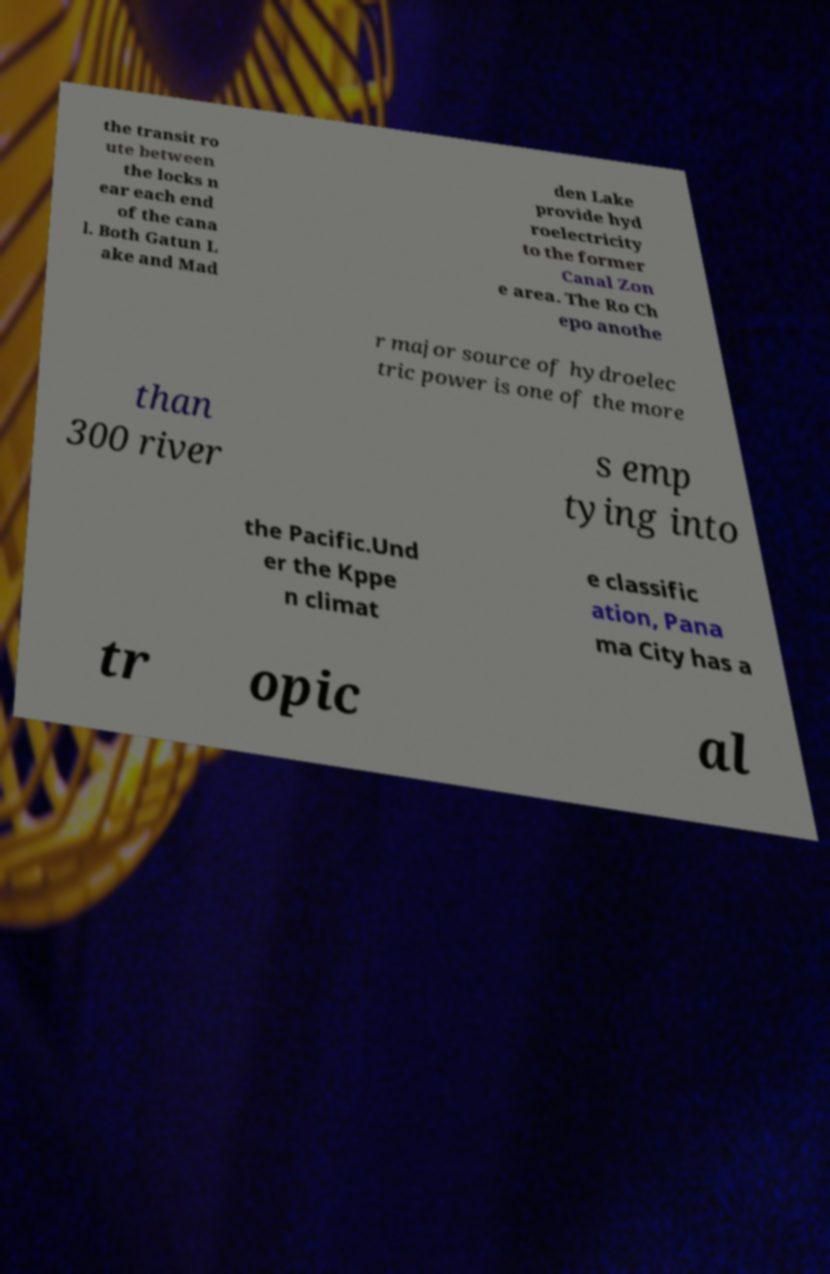Please identify and transcribe the text found in this image. the transit ro ute between the locks n ear each end of the cana l. Both Gatun L ake and Mad den Lake provide hyd roelectricity to the former Canal Zon e area. The Ro Ch epo anothe r major source of hydroelec tric power is one of the more than 300 river s emp tying into the Pacific.Und er the Kppe n climat e classific ation, Pana ma City has a tr opic al 